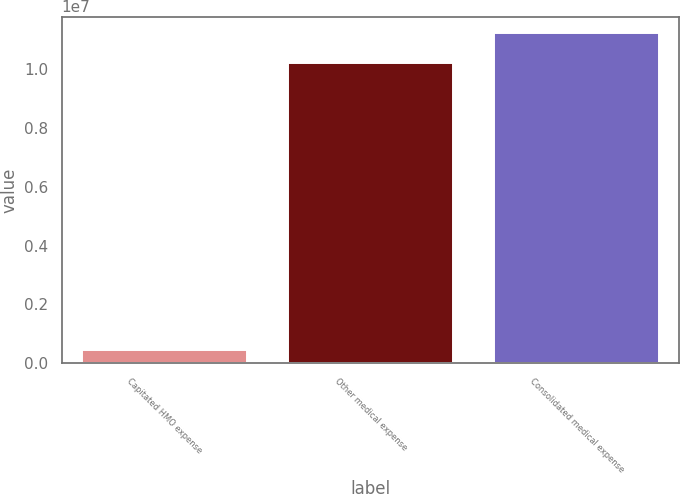Convert chart to OTSL. <chart><loc_0><loc_0><loc_500><loc_500><bar_chart><fcel>Capitated HMO expense<fcel>Other medical expense<fcel>Consolidated medical expense<nl><fcel>465231<fcel>1.02044e+07<fcel>1.12249e+07<nl></chart> 